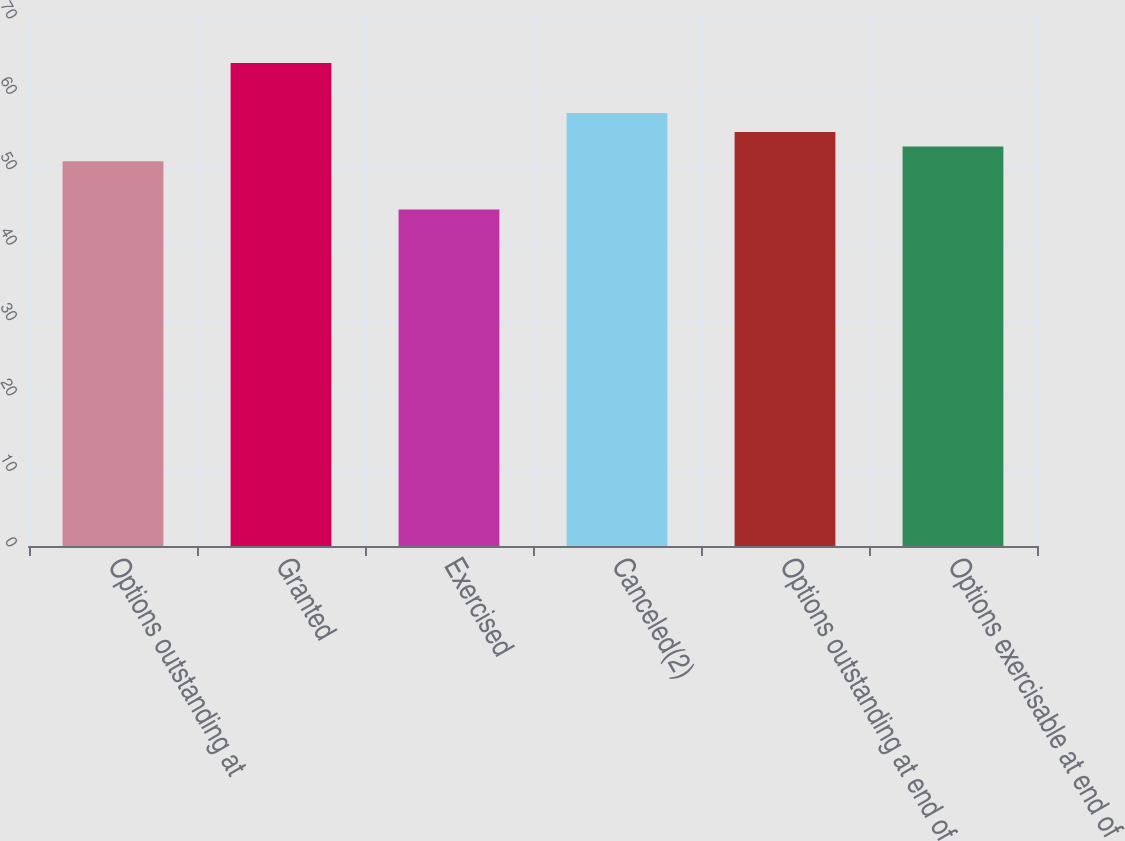Convert chart. <chart><loc_0><loc_0><loc_500><loc_500><bar_chart><fcel>Options outstanding at<fcel>Granted<fcel>Exercised<fcel>Canceled(2)<fcel>Options outstanding at end of<fcel>Options exercisable at end of<nl><fcel>51.01<fcel>64.05<fcel>44.6<fcel>57.41<fcel>54.9<fcel>52.95<nl></chart> 